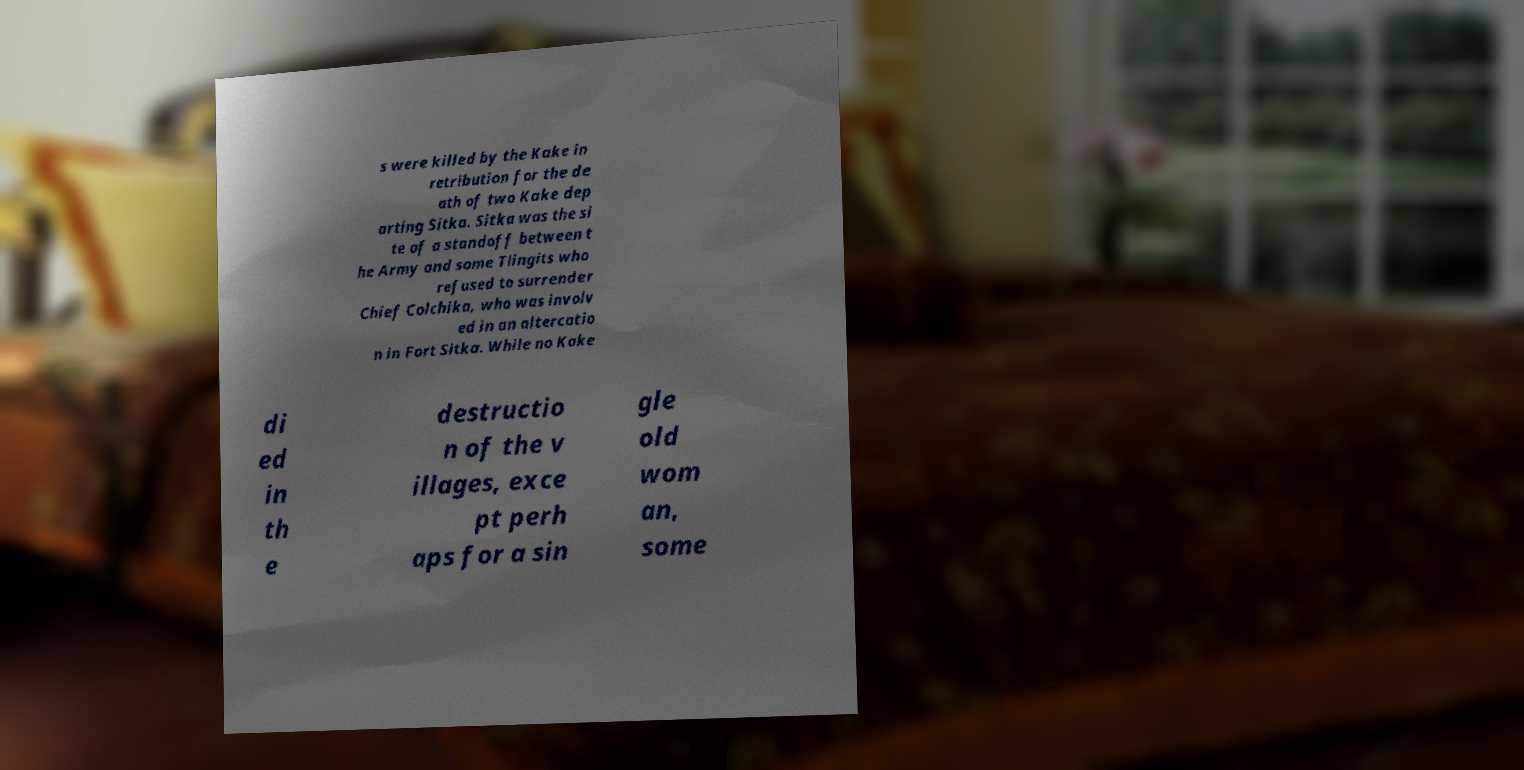Please read and relay the text visible in this image. What does it say? s were killed by the Kake in retribution for the de ath of two Kake dep arting Sitka. Sitka was the si te of a standoff between t he Army and some Tlingits who refused to surrender Chief Colchika, who was involv ed in an altercatio n in Fort Sitka. While no Kake di ed in th e destructio n of the v illages, exce pt perh aps for a sin gle old wom an, some 